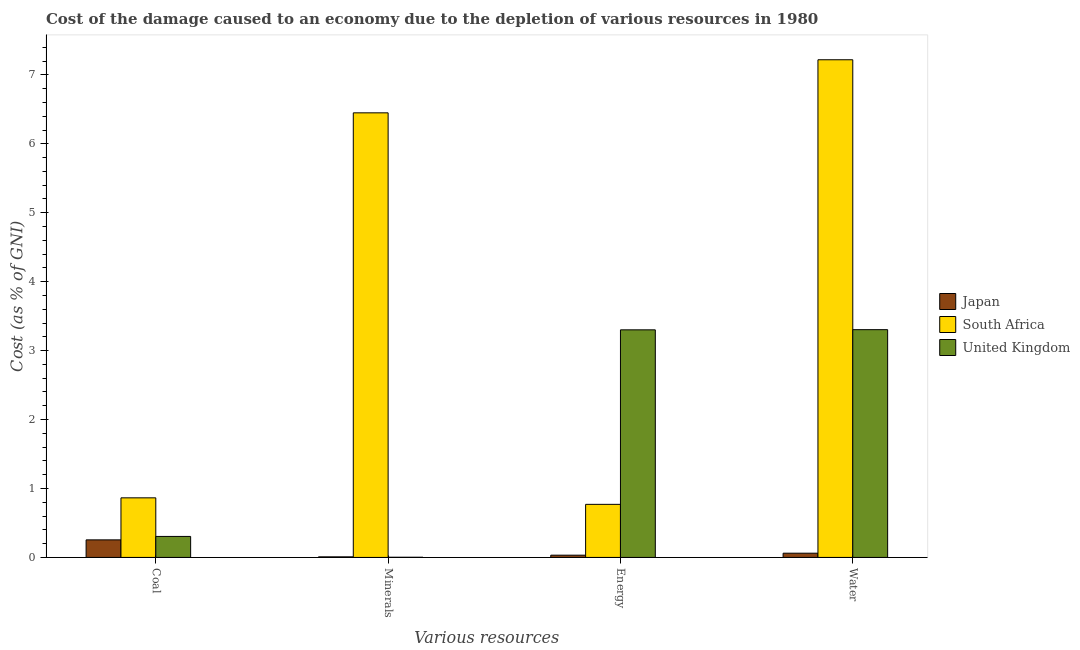Are the number of bars on each tick of the X-axis equal?
Offer a terse response. Yes. How many bars are there on the 1st tick from the left?
Your answer should be very brief. 3. What is the label of the 1st group of bars from the left?
Provide a succinct answer. Coal. What is the cost of damage due to depletion of minerals in Japan?
Offer a very short reply. 0.01. Across all countries, what is the maximum cost of damage due to depletion of energy?
Provide a succinct answer. 3.3. Across all countries, what is the minimum cost of damage due to depletion of energy?
Provide a succinct answer. 0.03. In which country was the cost of damage due to depletion of coal maximum?
Provide a succinct answer. South Africa. In which country was the cost of damage due to depletion of water minimum?
Your answer should be compact. Japan. What is the total cost of damage due to depletion of coal in the graph?
Your response must be concise. 1.42. What is the difference between the cost of damage due to depletion of energy in Japan and that in South Africa?
Make the answer very short. -0.74. What is the difference between the cost of damage due to depletion of minerals in Japan and the cost of damage due to depletion of coal in United Kingdom?
Your answer should be compact. -0.3. What is the average cost of damage due to depletion of energy per country?
Provide a succinct answer. 1.37. What is the difference between the cost of damage due to depletion of coal and cost of damage due to depletion of water in United Kingdom?
Your answer should be compact. -3. In how many countries, is the cost of damage due to depletion of water greater than 2 %?
Your answer should be very brief. 2. What is the ratio of the cost of damage due to depletion of water in South Africa to that in Japan?
Keep it short and to the point. 117.68. Is the cost of damage due to depletion of water in South Africa less than that in Japan?
Keep it short and to the point. No. What is the difference between the highest and the second highest cost of damage due to depletion of water?
Provide a short and direct response. 3.92. What is the difference between the highest and the lowest cost of damage due to depletion of coal?
Ensure brevity in your answer.  0.61. In how many countries, is the cost of damage due to depletion of energy greater than the average cost of damage due to depletion of energy taken over all countries?
Your answer should be very brief. 1. Is the sum of the cost of damage due to depletion of coal in United Kingdom and South Africa greater than the maximum cost of damage due to depletion of minerals across all countries?
Make the answer very short. No. What does the 2nd bar from the right in Coal represents?
Provide a short and direct response. South Africa. Is it the case that in every country, the sum of the cost of damage due to depletion of coal and cost of damage due to depletion of minerals is greater than the cost of damage due to depletion of energy?
Offer a very short reply. No. How many countries are there in the graph?
Offer a very short reply. 3. What is the difference between two consecutive major ticks on the Y-axis?
Keep it short and to the point. 1. Are the values on the major ticks of Y-axis written in scientific E-notation?
Provide a succinct answer. No. Does the graph contain any zero values?
Give a very brief answer. No. Does the graph contain grids?
Keep it short and to the point. No. What is the title of the graph?
Your answer should be very brief. Cost of the damage caused to an economy due to the depletion of various resources in 1980 . Does "South Asia" appear as one of the legend labels in the graph?
Ensure brevity in your answer.  No. What is the label or title of the X-axis?
Provide a short and direct response. Various resources. What is the label or title of the Y-axis?
Provide a succinct answer. Cost (as % of GNI). What is the Cost (as % of GNI) of Japan in Coal?
Provide a short and direct response. 0.25. What is the Cost (as % of GNI) of South Africa in Coal?
Your answer should be very brief. 0.86. What is the Cost (as % of GNI) in United Kingdom in Coal?
Keep it short and to the point. 0.3. What is the Cost (as % of GNI) in Japan in Minerals?
Provide a short and direct response. 0.01. What is the Cost (as % of GNI) of South Africa in Minerals?
Give a very brief answer. 6.45. What is the Cost (as % of GNI) in United Kingdom in Minerals?
Provide a short and direct response. 0. What is the Cost (as % of GNI) of Japan in Energy?
Ensure brevity in your answer.  0.03. What is the Cost (as % of GNI) in South Africa in Energy?
Your answer should be compact. 0.77. What is the Cost (as % of GNI) in United Kingdom in Energy?
Ensure brevity in your answer.  3.3. What is the Cost (as % of GNI) in Japan in Water?
Give a very brief answer. 0.06. What is the Cost (as % of GNI) of South Africa in Water?
Offer a very short reply. 7.22. What is the Cost (as % of GNI) in United Kingdom in Water?
Offer a terse response. 3.3. Across all Various resources, what is the maximum Cost (as % of GNI) in Japan?
Offer a very short reply. 0.25. Across all Various resources, what is the maximum Cost (as % of GNI) of South Africa?
Your answer should be very brief. 7.22. Across all Various resources, what is the maximum Cost (as % of GNI) of United Kingdom?
Your answer should be very brief. 3.3. Across all Various resources, what is the minimum Cost (as % of GNI) in Japan?
Keep it short and to the point. 0.01. Across all Various resources, what is the minimum Cost (as % of GNI) in South Africa?
Provide a short and direct response. 0.77. Across all Various resources, what is the minimum Cost (as % of GNI) of United Kingdom?
Ensure brevity in your answer.  0. What is the total Cost (as % of GNI) of Japan in the graph?
Your response must be concise. 0.36. What is the total Cost (as % of GNI) in South Africa in the graph?
Make the answer very short. 15.3. What is the total Cost (as % of GNI) of United Kingdom in the graph?
Make the answer very short. 6.91. What is the difference between the Cost (as % of GNI) in Japan in Coal and that in Minerals?
Your answer should be very brief. 0.25. What is the difference between the Cost (as % of GNI) in South Africa in Coal and that in Minerals?
Your answer should be very brief. -5.59. What is the difference between the Cost (as % of GNI) of United Kingdom in Coal and that in Minerals?
Make the answer very short. 0.3. What is the difference between the Cost (as % of GNI) in Japan in Coal and that in Energy?
Give a very brief answer. 0.22. What is the difference between the Cost (as % of GNI) in South Africa in Coal and that in Energy?
Provide a short and direct response. 0.09. What is the difference between the Cost (as % of GNI) in United Kingdom in Coal and that in Energy?
Keep it short and to the point. -3. What is the difference between the Cost (as % of GNI) in Japan in Coal and that in Water?
Keep it short and to the point. 0.19. What is the difference between the Cost (as % of GNI) of South Africa in Coal and that in Water?
Your answer should be very brief. -6.36. What is the difference between the Cost (as % of GNI) in United Kingdom in Coal and that in Water?
Offer a terse response. -3. What is the difference between the Cost (as % of GNI) in Japan in Minerals and that in Energy?
Make the answer very short. -0.02. What is the difference between the Cost (as % of GNI) in South Africa in Minerals and that in Energy?
Give a very brief answer. 5.68. What is the difference between the Cost (as % of GNI) in United Kingdom in Minerals and that in Energy?
Offer a terse response. -3.3. What is the difference between the Cost (as % of GNI) in Japan in Minerals and that in Water?
Ensure brevity in your answer.  -0.05. What is the difference between the Cost (as % of GNI) of South Africa in Minerals and that in Water?
Offer a terse response. -0.77. What is the difference between the Cost (as % of GNI) of United Kingdom in Minerals and that in Water?
Your answer should be compact. -3.3. What is the difference between the Cost (as % of GNI) of Japan in Energy and that in Water?
Offer a terse response. -0.03. What is the difference between the Cost (as % of GNI) of South Africa in Energy and that in Water?
Ensure brevity in your answer.  -6.45. What is the difference between the Cost (as % of GNI) of United Kingdom in Energy and that in Water?
Ensure brevity in your answer.  -0. What is the difference between the Cost (as % of GNI) in Japan in Coal and the Cost (as % of GNI) in South Africa in Minerals?
Your response must be concise. -6.19. What is the difference between the Cost (as % of GNI) of Japan in Coal and the Cost (as % of GNI) of United Kingdom in Minerals?
Your response must be concise. 0.25. What is the difference between the Cost (as % of GNI) in South Africa in Coal and the Cost (as % of GNI) in United Kingdom in Minerals?
Your response must be concise. 0.86. What is the difference between the Cost (as % of GNI) in Japan in Coal and the Cost (as % of GNI) in South Africa in Energy?
Provide a short and direct response. -0.52. What is the difference between the Cost (as % of GNI) in Japan in Coal and the Cost (as % of GNI) in United Kingdom in Energy?
Ensure brevity in your answer.  -3.05. What is the difference between the Cost (as % of GNI) of South Africa in Coal and the Cost (as % of GNI) of United Kingdom in Energy?
Provide a short and direct response. -2.44. What is the difference between the Cost (as % of GNI) in Japan in Coal and the Cost (as % of GNI) in South Africa in Water?
Give a very brief answer. -6.96. What is the difference between the Cost (as % of GNI) in Japan in Coal and the Cost (as % of GNI) in United Kingdom in Water?
Ensure brevity in your answer.  -3.05. What is the difference between the Cost (as % of GNI) of South Africa in Coal and the Cost (as % of GNI) of United Kingdom in Water?
Keep it short and to the point. -2.44. What is the difference between the Cost (as % of GNI) of Japan in Minerals and the Cost (as % of GNI) of South Africa in Energy?
Provide a short and direct response. -0.76. What is the difference between the Cost (as % of GNI) of Japan in Minerals and the Cost (as % of GNI) of United Kingdom in Energy?
Give a very brief answer. -3.29. What is the difference between the Cost (as % of GNI) of South Africa in Minerals and the Cost (as % of GNI) of United Kingdom in Energy?
Ensure brevity in your answer.  3.15. What is the difference between the Cost (as % of GNI) of Japan in Minerals and the Cost (as % of GNI) of South Africa in Water?
Your answer should be very brief. -7.21. What is the difference between the Cost (as % of GNI) of Japan in Minerals and the Cost (as % of GNI) of United Kingdom in Water?
Ensure brevity in your answer.  -3.3. What is the difference between the Cost (as % of GNI) in South Africa in Minerals and the Cost (as % of GNI) in United Kingdom in Water?
Keep it short and to the point. 3.15. What is the difference between the Cost (as % of GNI) in Japan in Energy and the Cost (as % of GNI) in South Africa in Water?
Provide a succinct answer. -7.19. What is the difference between the Cost (as % of GNI) of Japan in Energy and the Cost (as % of GNI) of United Kingdom in Water?
Provide a succinct answer. -3.27. What is the difference between the Cost (as % of GNI) of South Africa in Energy and the Cost (as % of GNI) of United Kingdom in Water?
Keep it short and to the point. -2.53. What is the average Cost (as % of GNI) of Japan per Various resources?
Make the answer very short. 0.09. What is the average Cost (as % of GNI) in South Africa per Various resources?
Provide a succinct answer. 3.83. What is the average Cost (as % of GNI) of United Kingdom per Various resources?
Your answer should be very brief. 1.73. What is the difference between the Cost (as % of GNI) of Japan and Cost (as % of GNI) of South Africa in Coal?
Offer a very short reply. -0.61. What is the difference between the Cost (as % of GNI) of Japan and Cost (as % of GNI) of United Kingdom in Coal?
Your response must be concise. -0.05. What is the difference between the Cost (as % of GNI) in South Africa and Cost (as % of GNI) in United Kingdom in Coal?
Your response must be concise. 0.56. What is the difference between the Cost (as % of GNI) in Japan and Cost (as % of GNI) in South Africa in Minerals?
Provide a succinct answer. -6.44. What is the difference between the Cost (as % of GNI) of Japan and Cost (as % of GNI) of United Kingdom in Minerals?
Provide a succinct answer. 0.01. What is the difference between the Cost (as % of GNI) of South Africa and Cost (as % of GNI) of United Kingdom in Minerals?
Your answer should be very brief. 6.45. What is the difference between the Cost (as % of GNI) of Japan and Cost (as % of GNI) of South Africa in Energy?
Ensure brevity in your answer.  -0.74. What is the difference between the Cost (as % of GNI) in Japan and Cost (as % of GNI) in United Kingdom in Energy?
Provide a short and direct response. -3.27. What is the difference between the Cost (as % of GNI) of South Africa and Cost (as % of GNI) of United Kingdom in Energy?
Your answer should be very brief. -2.53. What is the difference between the Cost (as % of GNI) in Japan and Cost (as % of GNI) in South Africa in Water?
Provide a succinct answer. -7.16. What is the difference between the Cost (as % of GNI) of Japan and Cost (as % of GNI) of United Kingdom in Water?
Your answer should be compact. -3.24. What is the difference between the Cost (as % of GNI) in South Africa and Cost (as % of GNI) in United Kingdom in Water?
Keep it short and to the point. 3.92. What is the ratio of the Cost (as % of GNI) of Japan in Coal to that in Minerals?
Offer a terse response. 30.27. What is the ratio of the Cost (as % of GNI) in South Africa in Coal to that in Minerals?
Provide a short and direct response. 0.13. What is the ratio of the Cost (as % of GNI) in United Kingdom in Coal to that in Minerals?
Your answer should be compact. 120.98. What is the ratio of the Cost (as % of GNI) of Japan in Coal to that in Energy?
Ensure brevity in your answer.  7.82. What is the ratio of the Cost (as % of GNI) in South Africa in Coal to that in Energy?
Your answer should be compact. 1.12. What is the ratio of the Cost (as % of GNI) in United Kingdom in Coal to that in Energy?
Provide a succinct answer. 0.09. What is the ratio of the Cost (as % of GNI) in Japan in Coal to that in Water?
Provide a short and direct response. 4.15. What is the ratio of the Cost (as % of GNI) in South Africa in Coal to that in Water?
Your answer should be compact. 0.12. What is the ratio of the Cost (as % of GNI) of United Kingdom in Coal to that in Water?
Your response must be concise. 0.09. What is the ratio of the Cost (as % of GNI) in Japan in Minerals to that in Energy?
Ensure brevity in your answer.  0.26. What is the ratio of the Cost (as % of GNI) of South Africa in Minerals to that in Energy?
Your answer should be compact. 8.38. What is the ratio of the Cost (as % of GNI) in United Kingdom in Minerals to that in Energy?
Provide a succinct answer. 0. What is the ratio of the Cost (as % of GNI) of Japan in Minerals to that in Water?
Keep it short and to the point. 0.14. What is the ratio of the Cost (as % of GNI) in South Africa in Minerals to that in Water?
Offer a very short reply. 0.89. What is the ratio of the Cost (as % of GNI) of United Kingdom in Minerals to that in Water?
Offer a terse response. 0. What is the ratio of the Cost (as % of GNI) in Japan in Energy to that in Water?
Your answer should be very brief. 0.53. What is the ratio of the Cost (as % of GNI) in South Africa in Energy to that in Water?
Your answer should be very brief. 0.11. What is the difference between the highest and the second highest Cost (as % of GNI) of Japan?
Provide a succinct answer. 0.19. What is the difference between the highest and the second highest Cost (as % of GNI) of South Africa?
Provide a short and direct response. 0.77. What is the difference between the highest and the second highest Cost (as % of GNI) in United Kingdom?
Provide a short and direct response. 0. What is the difference between the highest and the lowest Cost (as % of GNI) in Japan?
Provide a succinct answer. 0.25. What is the difference between the highest and the lowest Cost (as % of GNI) in South Africa?
Your response must be concise. 6.45. What is the difference between the highest and the lowest Cost (as % of GNI) of United Kingdom?
Provide a succinct answer. 3.3. 